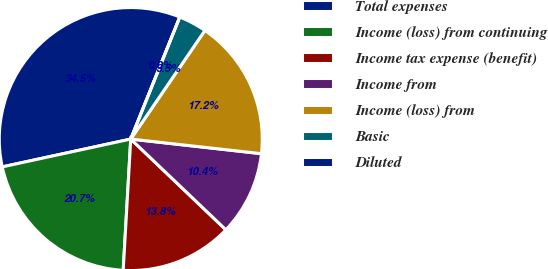<chart> <loc_0><loc_0><loc_500><loc_500><pie_chart><fcel>Total expenses<fcel>Income (loss) from continuing<fcel>Income tax expense (benefit)<fcel>Income from<fcel>Income (loss) from<fcel>Basic<fcel>Diluted<nl><fcel>34.48%<fcel>20.69%<fcel>13.79%<fcel>10.35%<fcel>17.24%<fcel>3.45%<fcel>0.0%<nl></chart> 